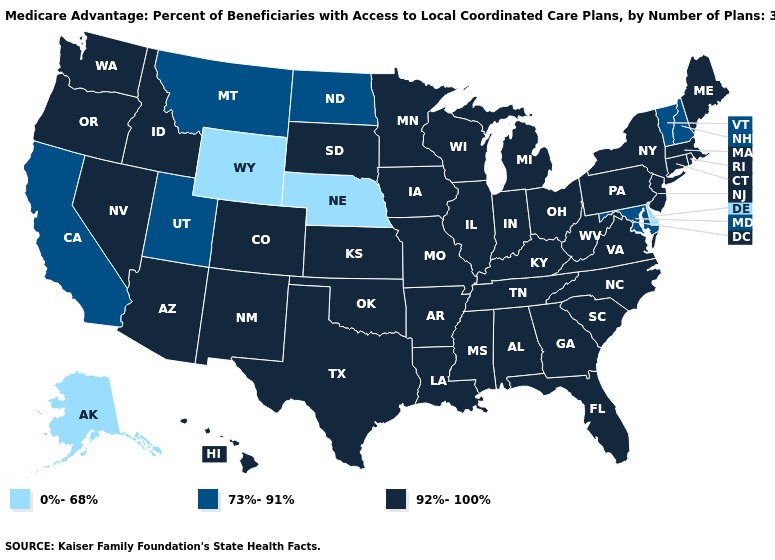What is the value of Florida?
Give a very brief answer. 92%-100%. What is the highest value in the USA?
Write a very short answer. 92%-100%. Does Indiana have a higher value than North Dakota?
Give a very brief answer. Yes. Does Wisconsin have a higher value than Ohio?
Give a very brief answer. No. Name the states that have a value in the range 73%-91%?
Give a very brief answer. California, Maryland, Montana, North Dakota, New Hampshire, Utah, Vermont. Does the map have missing data?
Short answer required. No. Is the legend a continuous bar?
Quick response, please. No. Among the states that border Oklahoma , which have the highest value?
Quick response, please. Colorado, Kansas, Missouri, New Mexico, Texas, Arkansas. Name the states that have a value in the range 73%-91%?
Quick response, please. California, Maryland, Montana, North Dakota, New Hampshire, Utah, Vermont. Name the states that have a value in the range 73%-91%?
Answer briefly. California, Maryland, Montana, North Dakota, New Hampshire, Utah, Vermont. What is the value of North Dakota?
Write a very short answer. 73%-91%. What is the value of New Hampshire?
Short answer required. 73%-91%. Name the states that have a value in the range 73%-91%?
Answer briefly. California, Maryland, Montana, North Dakota, New Hampshire, Utah, Vermont. Does the map have missing data?
Concise answer only. No. What is the highest value in the MidWest ?
Answer briefly. 92%-100%. 